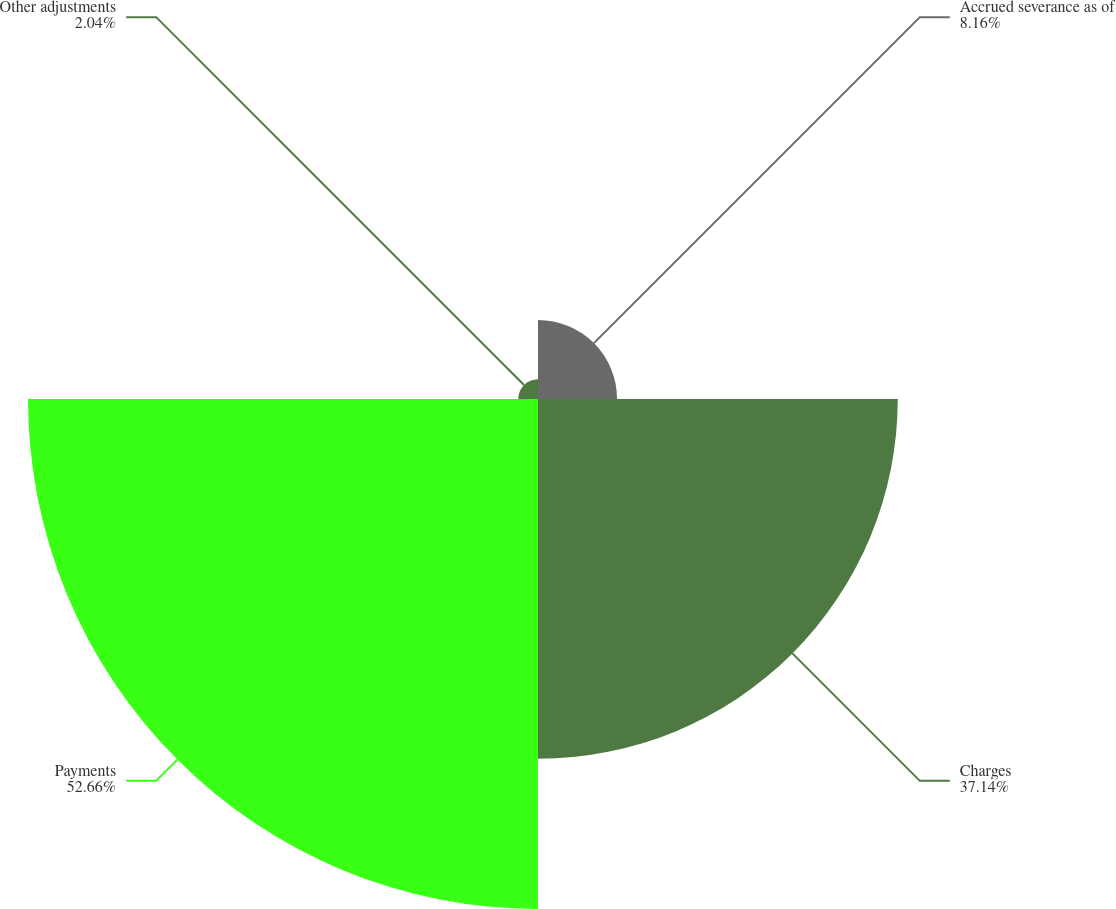Convert chart. <chart><loc_0><loc_0><loc_500><loc_500><pie_chart><fcel>Accrued severance as of<fcel>Charges<fcel>Payments<fcel>Other adjustments<nl><fcel>8.16%<fcel>37.14%<fcel>52.65%<fcel>2.04%<nl></chart> 